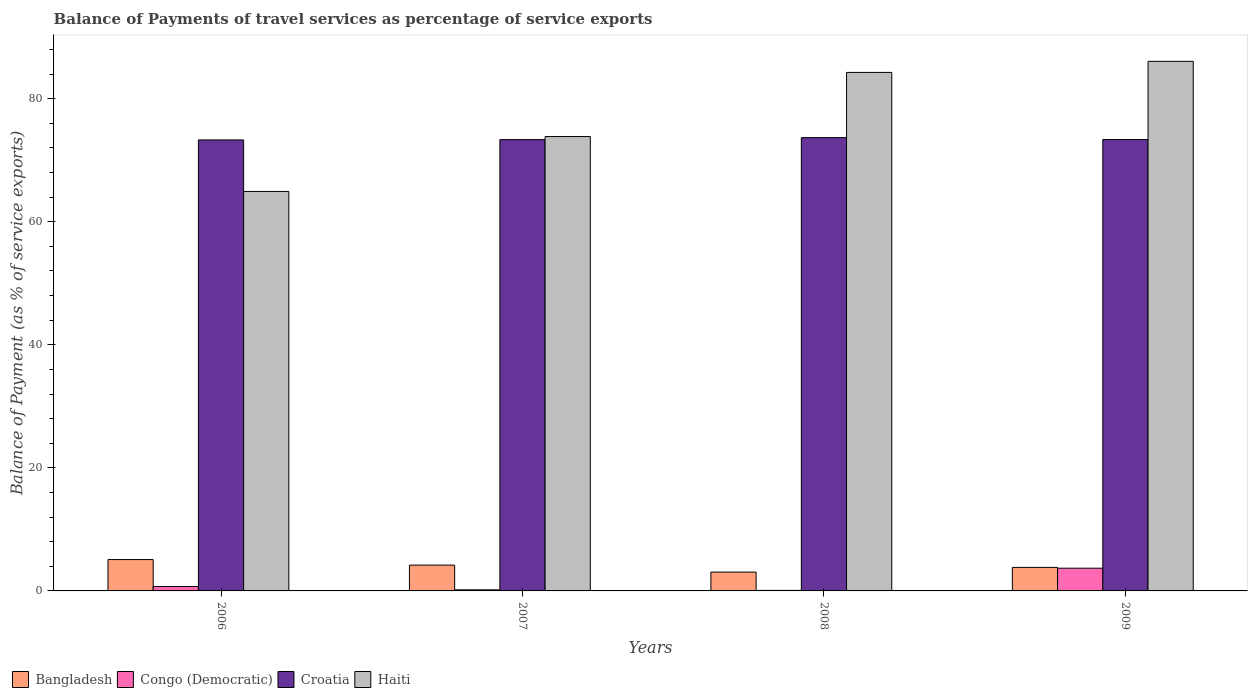Are the number of bars on each tick of the X-axis equal?
Give a very brief answer. Yes. How many bars are there on the 4th tick from the left?
Your answer should be compact. 4. How many bars are there on the 4th tick from the right?
Your response must be concise. 4. What is the label of the 1st group of bars from the left?
Your response must be concise. 2006. In how many cases, is the number of bars for a given year not equal to the number of legend labels?
Give a very brief answer. 0. What is the balance of payments of travel services in Croatia in 2008?
Give a very brief answer. 73.68. Across all years, what is the maximum balance of payments of travel services in Bangladesh?
Ensure brevity in your answer.  5.1. Across all years, what is the minimum balance of payments of travel services in Bangladesh?
Offer a terse response. 3.06. In which year was the balance of payments of travel services in Congo (Democratic) maximum?
Ensure brevity in your answer.  2009. What is the total balance of payments of travel services in Bangladesh in the graph?
Offer a very short reply. 16.17. What is the difference between the balance of payments of travel services in Haiti in 2007 and that in 2009?
Make the answer very short. -12.22. What is the difference between the balance of payments of travel services in Croatia in 2008 and the balance of payments of travel services in Bangladesh in 2009?
Ensure brevity in your answer.  69.85. What is the average balance of payments of travel services in Congo (Democratic) per year?
Your answer should be very brief. 1.17. In the year 2009, what is the difference between the balance of payments of travel services in Bangladesh and balance of payments of travel services in Croatia?
Your answer should be compact. -69.55. What is the ratio of the balance of payments of travel services in Bangladesh in 2007 to that in 2009?
Your response must be concise. 1.1. Is the balance of payments of travel services in Haiti in 2006 less than that in 2007?
Provide a short and direct response. Yes. Is the difference between the balance of payments of travel services in Bangladesh in 2006 and 2007 greater than the difference between the balance of payments of travel services in Croatia in 2006 and 2007?
Your answer should be very brief. Yes. What is the difference between the highest and the second highest balance of payments of travel services in Haiti?
Give a very brief answer. 1.8. What is the difference between the highest and the lowest balance of payments of travel services in Croatia?
Make the answer very short. 0.37. Is it the case that in every year, the sum of the balance of payments of travel services in Congo (Democratic) and balance of payments of travel services in Croatia is greater than the sum of balance of payments of travel services in Haiti and balance of payments of travel services in Bangladesh?
Offer a terse response. No. What does the 2nd bar from the left in 2008 represents?
Give a very brief answer. Congo (Democratic). What does the 3rd bar from the right in 2008 represents?
Your response must be concise. Congo (Democratic). How many years are there in the graph?
Offer a very short reply. 4. Are the values on the major ticks of Y-axis written in scientific E-notation?
Provide a short and direct response. No. Does the graph contain any zero values?
Give a very brief answer. No. Does the graph contain grids?
Your answer should be compact. No. What is the title of the graph?
Your response must be concise. Balance of Payments of travel services as percentage of service exports. What is the label or title of the Y-axis?
Keep it short and to the point. Balance of Payment (as % of service exports). What is the Balance of Payment (as % of service exports) in Bangladesh in 2006?
Your answer should be compact. 5.1. What is the Balance of Payment (as % of service exports) in Congo (Democratic) in 2006?
Make the answer very short. 0.72. What is the Balance of Payment (as % of service exports) in Croatia in 2006?
Your answer should be very brief. 73.3. What is the Balance of Payment (as % of service exports) of Haiti in 2006?
Offer a very short reply. 64.93. What is the Balance of Payment (as % of service exports) in Bangladesh in 2007?
Ensure brevity in your answer.  4.19. What is the Balance of Payment (as % of service exports) in Congo (Democratic) in 2007?
Provide a short and direct response. 0.18. What is the Balance of Payment (as % of service exports) in Croatia in 2007?
Provide a short and direct response. 73.36. What is the Balance of Payment (as % of service exports) in Haiti in 2007?
Make the answer very short. 73.85. What is the Balance of Payment (as % of service exports) of Bangladesh in 2008?
Your answer should be very brief. 3.06. What is the Balance of Payment (as % of service exports) of Congo (Democratic) in 2008?
Your answer should be compact. 0.08. What is the Balance of Payment (as % of service exports) in Croatia in 2008?
Make the answer very short. 73.68. What is the Balance of Payment (as % of service exports) of Haiti in 2008?
Provide a short and direct response. 84.28. What is the Balance of Payment (as % of service exports) in Bangladesh in 2009?
Provide a succinct answer. 3.83. What is the Balance of Payment (as % of service exports) of Congo (Democratic) in 2009?
Your answer should be compact. 3.69. What is the Balance of Payment (as % of service exports) in Croatia in 2009?
Your response must be concise. 73.37. What is the Balance of Payment (as % of service exports) of Haiti in 2009?
Make the answer very short. 86.08. Across all years, what is the maximum Balance of Payment (as % of service exports) of Bangladesh?
Your answer should be compact. 5.1. Across all years, what is the maximum Balance of Payment (as % of service exports) of Congo (Democratic)?
Make the answer very short. 3.69. Across all years, what is the maximum Balance of Payment (as % of service exports) of Croatia?
Offer a very short reply. 73.68. Across all years, what is the maximum Balance of Payment (as % of service exports) in Haiti?
Provide a short and direct response. 86.08. Across all years, what is the minimum Balance of Payment (as % of service exports) of Bangladesh?
Offer a very short reply. 3.06. Across all years, what is the minimum Balance of Payment (as % of service exports) of Congo (Democratic)?
Offer a very short reply. 0.08. Across all years, what is the minimum Balance of Payment (as % of service exports) in Croatia?
Your answer should be compact. 73.3. Across all years, what is the minimum Balance of Payment (as % of service exports) of Haiti?
Keep it short and to the point. 64.93. What is the total Balance of Payment (as % of service exports) in Bangladesh in the graph?
Offer a very short reply. 16.17. What is the total Balance of Payment (as % of service exports) in Congo (Democratic) in the graph?
Offer a very short reply. 4.67. What is the total Balance of Payment (as % of service exports) of Croatia in the graph?
Offer a very short reply. 293.71. What is the total Balance of Payment (as % of service exports) in Haiti in the graph?
Your answer should be compact. 309.14. What is the difference between the Balance of Payment (as % of service exports) of Bangladesh in 2006 and that in 2007?
Give a very brief answer. 0.9. What is the difference between the Balance of Payment (as % of service exports) in Congo (Democratic) in 2006 and that in 2007?
Offer a very short reply. 0.54. What is the difference between the Balance of Payment (as % of service exports) of Croatia in 2006 and that in 2007?
Make the answer very short. -0.05. What is the difference between the Balance of Payment (as % of service exports) in Haiti in 2006 and that in 2007?
Offer a very short reply. -8.92. What is the difference between the Balance of Payment (as % of service exports) in Bangladesh in 2006 and that in 2008?
Ensure brevity in your answer.  2.04. What is the difference between the Balance of Payment (as % of service exports) in Congo (Democratic) in 2006 and that in 2008?
Offer a terse response. 0.63. What is the difference between the Balance of Payment (as % of service exports) of Croatia in 2006 and that in 2008?
Ensure brevity in your answer.  -0.37. What is the difference between the Balance of Payment (as % of service exports) in Haiti in 2006 and that in 2008?
Your answer should be compact. -19.35. What is the difference between the Balance of Payment (as % of service exports) of Bangladesh in 2006 and that in 2009?
Your answer should be very brief. 1.27. What is the difference between the Balance of Payment (as % of service exports) in Congo (Democratic) in 2006 and that in 2009?
Your response must be concise. -2.98. What is the difference between the Balance of Payment (as % of service exports) in Croatia in 2006 and that in 2009?
Provide a short and direct response. -0.07. What is the difference between the Balance of Payment (as % of service exports) of Haiti in 2006 and that in 2009?
Ensure brevity in your answer.  -21.14. What is the difference between the Balance of Payment (as % of service exports) in Bangladesh in 2007 and that in 2008?
Your response must be concise. 1.13. What is the difference between the Balance of Payment (as % of service exports) of Congo (Democratic) in 2007 and that in 2008?
Make the answer very short. 0.09. What is the difference between the Balance of Payment (as % of service exports) of Croatia in 2007 and that in 2008?
Give a very brief answer. -0.32. What is the difference between the Balance of Payment (as % of service exports) of Haiti in 2007 and that in 2008?
Offer a very short reply. -10.43. What is the difference between the Balance of Payment (as % of service exports) of Bangladesh in 2007 and that in 2009?
Your answer should be very brief. 0.37. What is the difference between the Balance of Payment (as % of service exports) of Congo (Democratic) in 2007 and that in 2009?
Your answer should be very brief. -3.51. What is the difference between the Balance of Payment (as % of service exports) in Croatia in 2007 and that in 2009?
Provide a short and direct response. -0.02. What is the difference between the Balance of Payment (as % of service exports) in Haiti in 2007 and that in 2009?
Your answer should be very brief. -12.22. What is the difference between the Balance of Payment (as % of service exports) of Bangladesh in 2008 and that in 2009?
Ensure brevity in your answer.  -0.77. What is the difference between the Balance of Payment (as % of service exports) in Congo (Democratic) in 2008 and that in 2009?
Your response must be concise. -3.61. What is the difference between the Balance of Payment (as % of service exports) in Croatia in 2008 and that in 2009?
Your answer should be compact. 0.3. What is the difference between the Balance of Payment (as % of service exports) in Haiti in 2008 and that in 2009?
Ensure brevity in your answer.  -1.8. What is the difference between the Balance of Payment (as % of service exports) of Bangladesh in 2006 and the Balance of Payment (as % of service exports) of Congo (Democratic) in 2007?
Give a very brief answer. 4.92. What is the difference between the Balance of Payment (as % of service exports) of Bangladesh in 2006 and the Balance of Payment (as % of service exports) of Croatia in 2007?
Offer a very short reply. -68.26. What is the difference between the Balance of Payment (as % of service exports) in Bangladesh in 2006 and the Balance of Payment (as % of service exports) in Haiti in 2007?
Offer a terse response. -68.76. What is the difference between the Balance of Payment (as % of service exports) of Congo (Democratic) in 2006 and the Balance of Payment (as % of service exports) of Croatia in 2007?
Give a very brief answer. -72.64. What is the difference between the Balance of Payment (as % of service exports) in Congo (Democratic) in 2006 and the Balance of Payment (as % of service exports) in Haiti in 2007?
Make the answer very short. -73.14. What is the difference between the Balance of Payment (as % of service exports) of Croatia in 2006 and the Balance of Payment (as % of service exports) of Haiti in 2007?
Your answer should be compact. -0.55. What is the difference between the Balance of Payment (as % of service exports) in Bangladesh in 2006 and the Balance of Payment (as % of service exports) in Congo (Democratic) in 2008?
Ensure brevity in your answer.  5.01. What is the difference between the Balance of Payment (as % of service exports) in Bangladesh in 2006 and the Balance of Payment (as % of service exports) in Croatia in 2008?
Keep it short and to the point. -68.58. What is the difference between the Balance of Payment (as % of service exports) in Bangladesh in 2006 and the Balance of Payment (as % of service exports) in Haiti in 2008?
Offer a very short reply. -79.18. What is the difference between the Balance of Payment (as % of service exports) of Congo (Democratic) in 2006 and the Balance of Payment (as % of service exports) of Croatia in 2008?
Your answer should be compact. -72.96. What is the difference between the Balance of Payment (as % of service exports) of Congo (Democratic) in 2006 and the Balance of Payment (as % of service exports) of Haiti in 2008?
Your response must be concise. -83.56. What is the difference between the Balance of Payment (as % of service exports) in Croatia in 2006 and the Balance of Payment (as % of service exports) in Haiti in 2008?
Make the answer very short. -10.97. What is the difference between the Balance of Payment (as % of service exports) in Bangladesh in 2006 and the Balance of Payment (as % of service exports) in Congo (Democratic) in 2009?
Your response must be concise. 1.4. What is the difference between the Balance of Payment (as % of service exports) in Bangladesh in 2006 and the Balance of Payment (as % of service exports) in Croatia in 2009?
Your response must be concise. -68.28. What is the difference between the Balance of Payment (as % of service exports) in Bangladesh in 2006 and the Balance of Payment (as % of service exports) in Haiti in 2009?
Your response must be concise. -80.98. What is the difference between the Balance of Payment (as % of service exports) of Congo (Democratic) in 2006 and the Balance of Payment (as % of service exports) of Croatia in 2009?
Ensure brevity in your answer.  -72.66. What is the difference between the Balance of Payment (as % of service exports) of Congo (Democratic) in 2006 and the Balance of Payment (as % of service exports) of Haiti in 2009?
Make the answer very short. -85.36. What is the difference between the Balance of Payment (as % of service exports) in Croatia in 2006 and the Balance of Payment (as % of service exports) in Haiti in 2009?
Give a very brief answer. -12.77. What is the difference between the Balance of Payment (as % of service exports) in Bangladesh in 2007 and the Balance of Payment (as % of service exports) in Congo (Democratic) in 2008?
Make the answer very short. 4.11. What is the difference between the Balance of Payment (as % of service exports) of Bangladesh in 2007 and the Balance of Payment (as % of service exports) of Croatia in 2008?
Your response must be concise. -69.48. What is the difference between the Balance of Payment (as % of service exports) in Bangladesh in 2007 and the Balance of Payment (as % of service exports) in Haiti in 2008?
Provide a short and direct response. -80.08. What is the difference between the Balance of Payment (as % of service exports) of Congo (Democratic) in 2007 and the Balance of Payment (as % of service exports) of Croatia in 2008?
Your answer should be very brief. -73.5. What is the difference between the Balance of Payment (as % of service exports) in Congo (Democratic) in 2007 and the Balance of Payment (as % of service exports) in Haiti in 2008?
Keep it short and to the point. -84.1. What is the difference between the Balance of Payment (as % of service exports) in Croatia in 2007 and the Balance of Payment (as % of service exports) in Haiti in 2008?
Ensure brevity in your answer.  -10.92. What is the difference between the Balance of Payment (as % of service exports) in Bangladesh in 2007 and the Balance of Payment (as % of service exports) in Congo (Democratic) in 2009?
Make the answer very short. 0.5. What is the difference between the Balance of Payment (as % of service exports) of Bangladesh in 2007 and the Balance of Payment (as % of service exports) of Croatia in 2009?
Offer a very short reply. -69.18. What is the difference between the Balance of Payment (as % of service exports) of Bangladesh in 2007 and the Balance of Payment (as % of service exports) of Haiti in 2009?
Keep it short and to the point. -81.88. What is the difference between the Balance of Payment (as % of service exports) in Congo (Democratic) in 2007 and the Balance of Payment (as % of service exports) in Croatia in 2009?
Your answer should be very brief. -73.19. What is the difference between the Balance of Payment (as % of service exports) of Congo (Democratic) in 2007 and the Balance of Payment (as % of service exports) of Haiti in 2009?
Your answer should be compact. -85.9. What is the difference between the Balance of Payment (as % of service exports) in Croatia in 2007 and the Balance of Payment (as % of service exports) in Haiti in 2009?
Your answer should be compact. -12.72. What is the difference between the Balance of Payment (as % of service exports) in Bangladesh in 2008 and the Balance of Payment (as % of service exports) in Congo (Democratic) in 2009?
Your answer should be compact. -0.63. What is the difference between the Balance of Payment (as % of service exports) in Bangladesh in 2008 and the Balance of Payment (as % of service exports) in Croatia in 2009?
Keep it short and to the point. -70.31. What is the difference between the Balance of Payment (as % of service exports) of Bangladesh in 2008 and the Balance of Payment (as % of service exports) of Haiti in 2009?
Offer a terse response. -83.01. What is the difference between the Balance of Payment (as % of service exports) of Congo (Democratic) in 2008 and the Balance of Payment (as % of service exports) of Croatia in 2009?
Provide a succinct answer. -73.29. What is the difference between the Balance of Payment (as % of service exports) of Congo (Democratic) in 2008 and the Balance of Payment (as % of service exports) of Haiti in 2009?
Provide a short and direct response. -85.99. What is the difference between the Balance of Payment (as % of service exports) in Croatia in 2008 and the Balance of Payment (as % of service exports) in Haiti in 2009?
Provide a short and direct response. -12.4. What is the average Balance of Payment (as % of service exports) in Bangladesh per year?
Offer a terse response. 4.04. What is the average Balance of Payment (as % of service exports) of Congo (Democratic) per year?
Offer a terse response. 1.17. What is the average Balance of Payment (as % of service exports) in Croatia per year?
Offer a terse response. 73.43. What is the average Balance of Payment (as % of service exports) of Haiti per year?
Your response must be concise. 77.28. In the year 2006, what is the difference between the Balance of Payment (as % of service exports) of Bangladesh and Balance of Payment (as % of service exports) of Congo (Democratic)?
Keep it short and to the point. 4.38. In the year 2006, what is the difference between the Balance of Payment (as % of service exports) of Bangladesh and Balance of Payment (as % of service exports) of Croatia?
Give a very brief answer. -68.21. In the year 2006, what is the difference between the Balance of Payment (as % of service exports) in Bangladesh and Balance of Payment (as % of service exports) in Haiti?
Your answer should be compact. -59.84. In the year 2006, what is the difference between the Balance of Payment (as % of service exports) of Congo (Democratic) and Balance of Payment (as % of service exports) of Croatia?
Ensure brevity in your answer.  -72.59. In the year 2006, what is the difference between the Balance of Payment (as % of service exports) in Congo (Democratic) and Balance of Payment (as % of service exports) in Haiti?
Provide a short and direct response. -64.21. In the year 2006, what is the difference between the Balance of Payment (as % of service exports) of Croatia and Balance of Payment (as % of service exports) of Haiti?
Your answer should be compact. 8.37. In the year 2007, what is the difference between the Balance of Payment (as % of service exports) of Bangladesh and Balance of Payment (as % of service exports) of Congo (Democratic)?
Ensure brevity in your answer.  4.01. In the year 2007, what is the difference between the Balance of Payment (as % of service exports) of Bangladesh and Balance of Payment (as % of service exports) of Croatia?
Give a very brief answer. -69.17. In the year 2007, what is the difference between the Balance of Payment (as % of service exports) in Bangladesh and Balance of Payment (as % of service exports) in Haiti?
Your answer should be compact. -69.66. In the year 2007, what is the difference between the Balance of Payment (as % of service exports) of Congo (Democratic) and Balance of Payment (as % of service exports) of Croatia?
Provide a short and direct response. -73.18. In the year 2007, what is the difference between the Balance of Payment (as % of service exports) of Congo (Democratic) and Balance of Payment (as % of service exports) of Haiti?
Keep it short and to the point. -73.67. In the year 2007, what is the difference between the Balance of Payment (as % of service exports) of Croatia and Balance of Payment (as % of service exports) of Haiti?
Your answer should be compact. -0.49. In the year 2008, what is the difference between the Balance of Payment (as % of service exports) of Bangladesh and Balance of Payment (as % of service exports) of Congo (Democratic)?
Make the answer very short. 2.98. In the year 2008, what is the difference between the Balance of Payment (as % of service exports) in Bangladesh and Balance of Payment (as % of service exports) in Croatia?
Your answer should be very brief. -70.62. In the year 2008, what is the difference between the Balance of Payment (as % of service exports) of Bangladesh and Balance of Payment (as % of service exports) of Haiti?
Keep it short and to the point. -81.22. In the year 2008, what is the difference between the Balance of Payment (as % of service exports) in Congo (Democratic) and Balance of Payment (as % of service exports) in Croatia?
Your response must be concise. -73.59. In the year 2008, what is the difference between the Balance of Payment (as % of service exports) in Congo (Democratic) and Balance of Payment (as % of service exports) in Haiti?
Provide a short and direct response. -84.19. In the year 2008, what is the difference between the Balance of Payment (as % of service exports) in Croatia and Balance of Payment (as % of service exports) in Haiti?
Give a very brief answer. -10.6. In the year 2009, what is the difference between the Balance of Payment (as % of service exports) of Bangladesh and Balance of Payment (as % of service exports) of Congo (Democratic)?
Your response must be concise. 0.13. In the year 2009, what is the difference between the Balance of Payment (as % of service exports) of Bangladesh and Balance of Payment (as % of service exports) of Croatia?
Provide a succinct answer. -69.55. In the year 2009, what is the difference between the Balance of Payment (as % of service exports) of Bangladesh and Balance of Payment (as % of service exports) of Haiti?
Provide a short and direct response. -82.25. In the year 2009, what is the difference between the Balance of Payment (as % of service exports) in Congo (Democratic) and Balance of Payment (as % of service exports) in Croatia?
Make the answer very short. -69.68. In the year 2009, what is the difference between the Balance of Payment (as % of service exports) of Congo (Democratic) and Balance of Payment (as % of service exports) of Haiti?
Your answer should be compact. -82.38. In the year 2009, what is the difference between the Balance of Payment (as % of service exports) in Croatia and Balance of Payment (as % of service exports) in Haiti?
Your response must be concise. -12.7. What is the ratio of the Balance of Payment (as % of service exports) in Bangladesh in 2006 to that in 2007?
Offer a terse response. 1.22. What is the ratio of the Balance of Payment (as % of service exports) of Congo (Democratic) in 2006 to that in 2007?
Ensure brevity in your answer.  4.01. What is the ratio of the Balance of Payment (as % of service exports) in Croatia in 2006 to that in 2007?
Provide a succinct answer. 1. What is the ratio of the Balance of Payment (as % of service exports) of Haiti in 2006 to that in 2007?
Offer a very short reply. 0.88. What is the ratio of the Balance of Payment (as % of service exports) in Bangladesh in 2006 to that in 2008?
Your answer should be very brief. 1.66. What is the ratio of the Balance of Payment (as % of service exports) in Congo (Democratic) in 2006 to that in 2008?
Make the answer very short. 8.47. What is the ratio of the Balance of Payment (as % of service exports) in Haiti in 2006 to that in 2008?
Offer a very short reply. 0.77. What is the ratio of the Balance of Payment (as % of service exports) of Bangladesh in 2006 to that in 2009?
Keep it short and to the point. 1.33. What is the ratio of the Balance of Payment (as % of service exports) of Congo (Democratic) in 2006 to that in 2009?
Your response must be concise. 0.19. What is the ratio of the Balance of Payment (as % of service exports) of Croatia in 2006 to that in 2009?
Your answer should be very brief. 1. What is the ratio of the Balance of Payment (as % of service exports) of Haiti in 2006 to that in 2009?
Provide a short and direct response. 0.75. What is the ratio of the Balance of Payment (as % of service exports) of Bangladesh in 2007 to that in 2008?
Ensure brevity in your answer.  1.37. What is the ratio of the Balance of Payment (as % of service exports) in Congo (Democratic) in 2007 to that in 2008?
Provide a succinct answer. 2.11. What is the ratio of the Balance of Payment (as % of service exports) of Croatia in 2007 to that in 2008?
Your answer should be compact. 1. What is the ratio of the Balance of Payment (as % of service exports) of Haiti in 2007 to that in 2008?
Your response must be concise. 0.88. What is the ratio of the Balance of Payment (as % of service exports) of Bangladesh in 2007 to that in 2009?
Your answer should be very brief. 1.1. What is the ratio of the Balance of Payment (as % of service exports) of Congo (Democratic) in 2007 to that in 2009?
Make the answer very short. 0.05. What is the ratio of the Balance of Payment (as % of service exports) of Haiti in 2007 to that in 2009?
Provide a succinct answer. 0.86. What is the ratio of the Balance of Payment (as % of service exports) of Bangladesh in 2008 to that in 2009?
Offer a terse response. 0.8. What is the ratio of the Balance of Payment (as % of service exports) of Congo (Democratic) in 2008 to that in 2009?
Give a very brief answer. 0.02. What is the ratio of the Balance of Payment (as % of service exports) in Croatia in 2008 to that in 2009?
Keep it short and to the point. 1. What is the ratio of the Balance of Payment (as % of service exports) of Haiti in 2008 to that in 2009?
Provide a short and direct response. 0.98. What is the difference between the highest and the second highest Balance of Payment (as % of service exports) in Bangladesh?
Your answer should be very brief. 0.9. What is the difference between the highest and the second highest Balance of Payment (as % of service exports) in Congo (Democratic)?
Ensure brevity in your answer.  2.98. What is the difference between the highest and the second highest Balance of Payment (as % of service exports) of Croatia?
Keep it short and to the point. 0.3. What is the difference between the highest and the second highest Balance of Payment (as % of service exports) of Haiti?
Your answer should be compact. 1.8. What is the difference between the highest and the lowest Balance of Payment (as % of service exports) of Bangladesh?
Provide a succinct answer. 2.04. What is the difference between the highest and the lowest Balance of Payment (as % of service exports) of Congo (Democratic)?
Your answer should be very brief. 3.61. What is the difference between the highest and the lowest Balance of Payment (as % of service exports) in Croatia?
Ensure brevity in your answer.  0.37. What is the difference between the highest and the lowest Balance of Payment (as % of service exports) in Haiti?
Your answer should be compact. 21.14. 